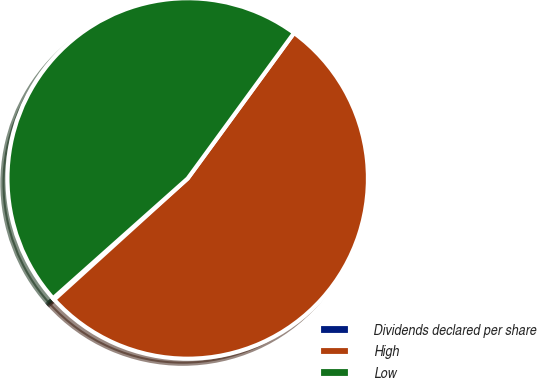Convert chart to OTSL. <chart><loc_0><loc_0><loc_500><loc_500><pie_chart><fcel>Dividends declared per share<fcel>High<fcel>Low<nl><fcel>0.15%<fcel>53.23%<fcel>46.62%<nl></chart> 